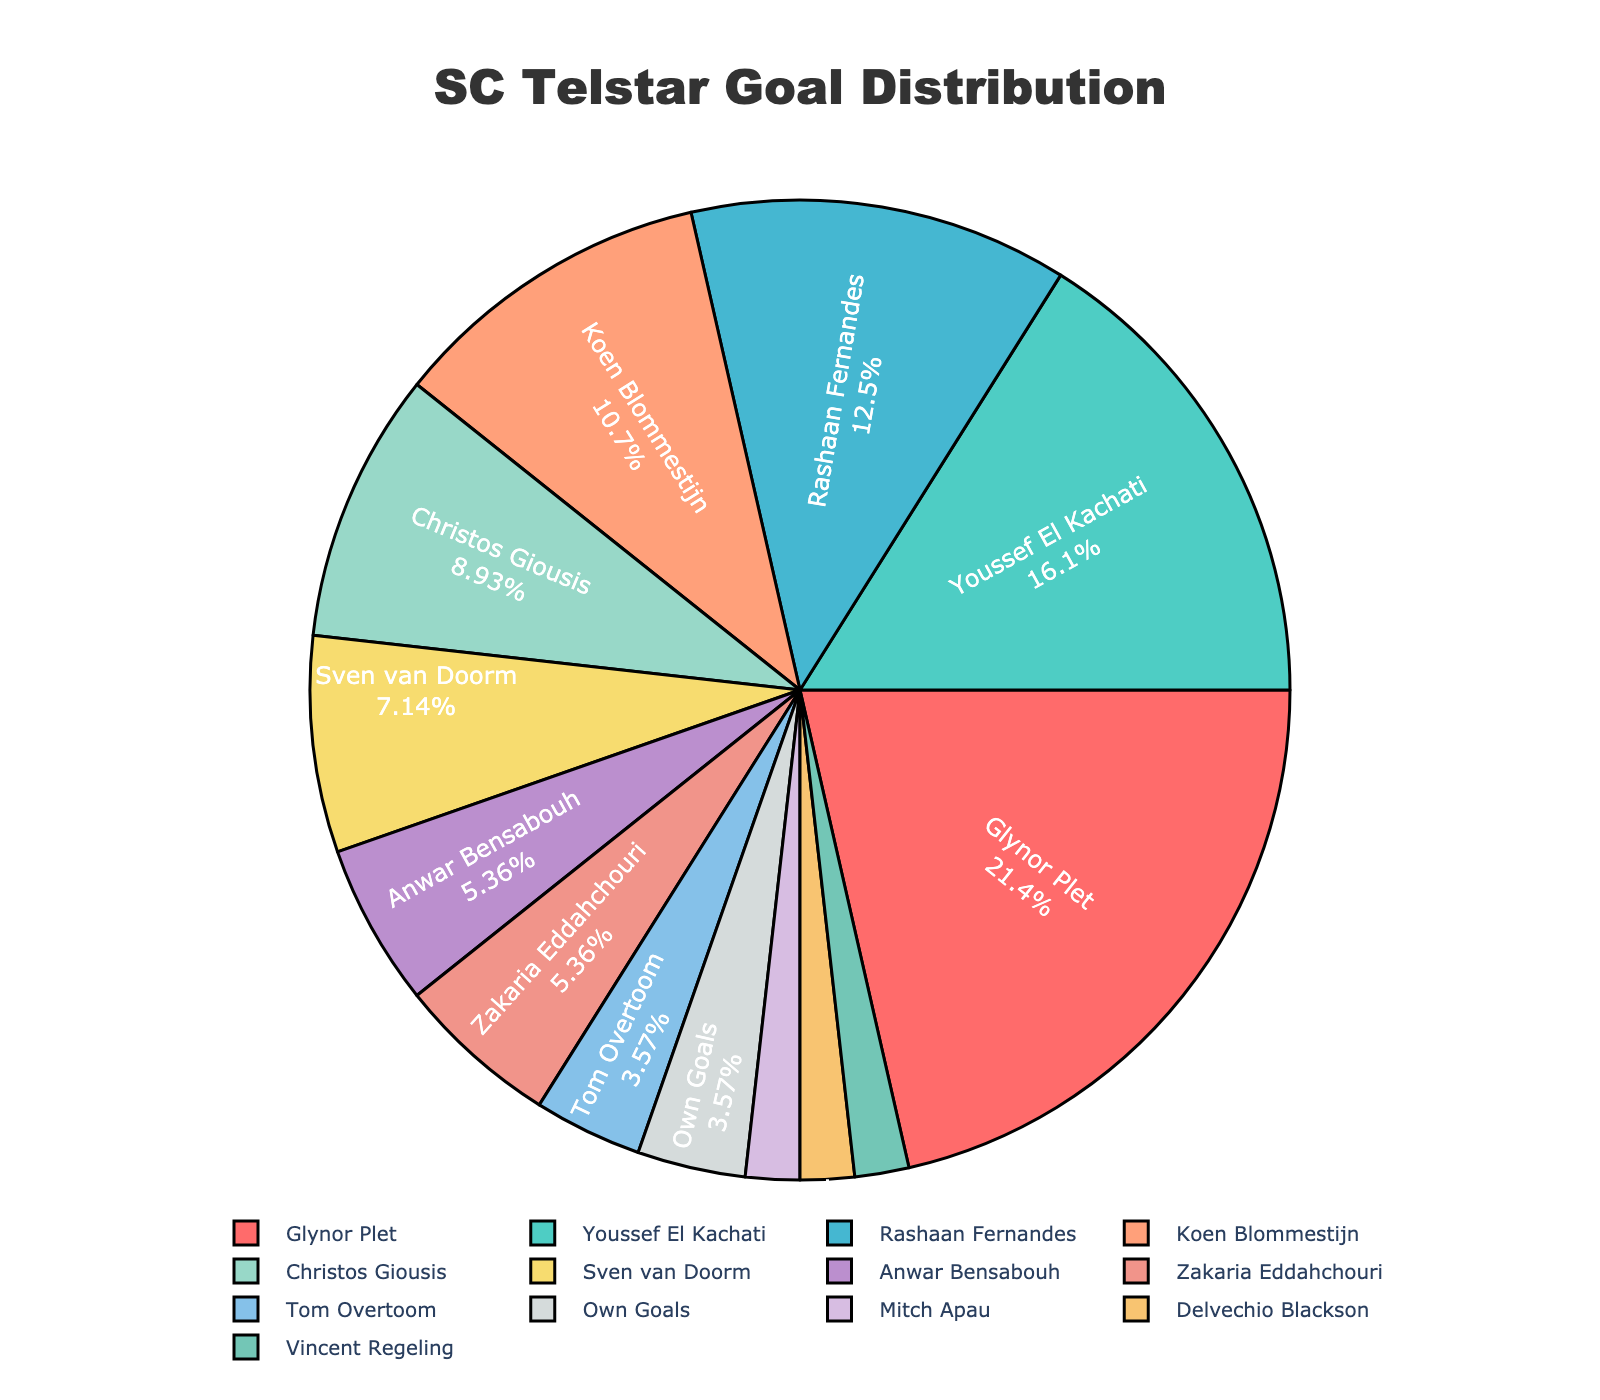What percentage of goals did Glynor Plet score? First, locate the segment labeled "Glynor Plet" on the pie chart, then read the percentage provided within or near his segment.
Answer: 29% Who scored the fewest goals for SC Telstar this season? Identify the smallest segment on the pie chart, noting the player's name within or near it, which should indicate the fewest goals scored.
Answer: Mitch Apau, Delvechio Blackson, or Vincent Regeling (1 goal each) Which player scored more goals: Youssef El Kachati or Rashaan Fernandes? Compare the pie chart segments for Youssef El Kachati and Rashaan Fernandes. The larger segment corresponds to the player who scored more goals.
Answer: Youssef El Kachati What is the combined percentage of goals scored by players who scored less than 5 goals? Identify all players who scored less than 5 goals. Sum their percentages as shown within or near their segments on the pie chart to get the combined percentage.
Answer: 16% How do the goals scored by Koen Blommestijn compare to the own goals? Compare the pie chart segments for Koen Blommestijn and Own Goals. Determine how the size of the segments and the percentage values compare.
Answer: Koen Blommestijn scored more What proportion of goals were scored by the top 3 goal scorers? Identify the top 3 goal scorers by looking at the largest segments in the pie chart (Glynor Plet, Youssef El Kachati, Rashaan Fernandes). Sum their percentages to get the proportion.
Answer: 65% Which player has a goal segment represented by a purple color? Identify the segment on the pie chart colored purple and note the player's name within or near it.
Answer: Christos Giousis How many players scored more goals than Sven van Doorm? Locate Sven van Doorm's segment and count the number of segments larger than his, corresponding to players who scored more goals.
Answer: 5 players Did Zakaria Eddahchouri and Anwar Bensabouh score an equal number of goals? Compare the pie chart segments for Zakaria Eddahchouri and Anwar Bensabouh to see if their segment sizes and percentages are equal.
Answer: Yes 